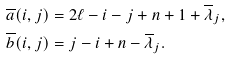<formula> <loc_0><loc_0><loc_500><loc_500>\overline { a } ( i , j ) & = 2 \ell - i - j + n + 1 + \overline { \lambda } _ { j } , \\ \overline { b } ( i , j ) & = j - i + n - \overline { \lambda } _ { j } .</formula> 